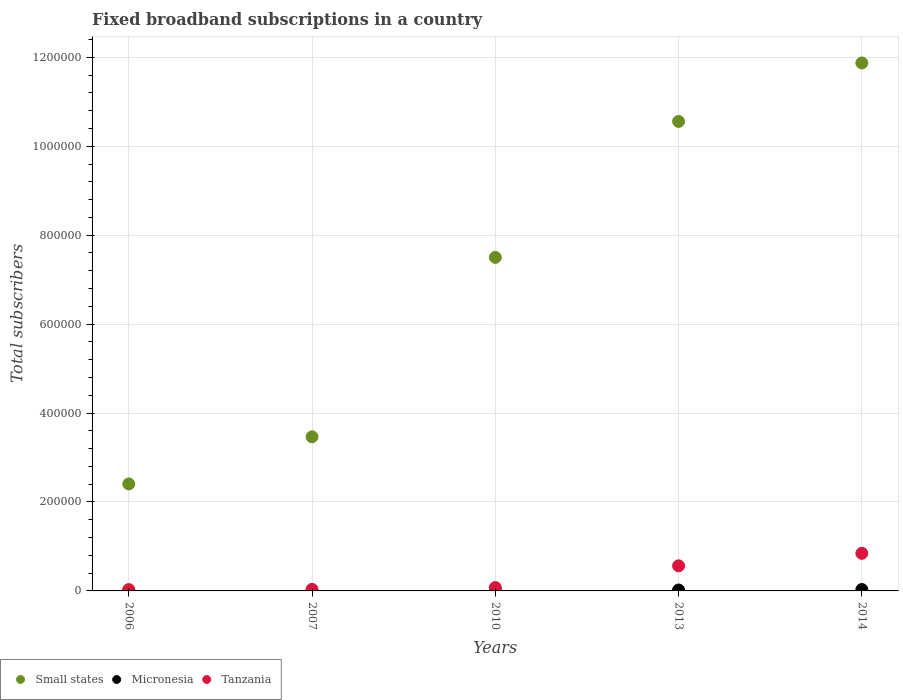How many different coloured dotlines are there?
Your answer should be very brief. 3. What is the number of broadband subscriptions in Tanzania in 2013?
Keep it short and to the point. 5.64e+04. Across all years, what is the maximum number of broadband subscriptions in Micronesia?
Make the answer very short. 3092. Across all years, what is the minimum number of broadband subscriptions in Tanzania?
Make the answer very short. 2998. In which year was the number of broadband subscriptions in Micronesia maximum?
Your answer should be very brief. 2014. In which year was the number of broadband subscriptions in Tanzania minimum?
Ensure brevity in your answer.  2006. What is the total number of broadband subscriptions in Small states in the graph?
Your response must be concise. 3.58e+06. What is the difference between the number of broadband subscriptions in Micronesia in 2007 and that in 2014?
Offer a very short reply. -2976. What is the difference between the number of broadband subscriptions in Micronesia in 2006 and the number of broadband subscriptions in Small states in 2013?
Offer a terse response. -1.06e+06. What is the average number of broadband subscriptions in Tanzania per year?
Offer a terse response. 3.10e+04. In the year 2007, what is the difference between the number of broadband subscriptions in Micronesia and number of broadband subscriptions in Small states?
Provide a short and direct response. -3.46e+05. What is the ratio of the number of broadband subscriptions in Small states in 2010 to that in 2013?
Keep it short and to the point. 0.71. Is the number of broadband subscriptions in Small states in 2006 less than that in 2007?
Your answer should be very brief. Yes. Is the difference between the number of broadband subscriptions in Micronesia in 2007 and 2013 greater than the difference between the number of broadband subscriptions in Small states in 2007 and 2013?
Provide a succinct answer. Yes. What is the difference between the highest and the second highest number of broadband subscriptions in Tanzania?
Keep it short and to the point. 2.82e+04. What is the difference between the highest and the lowest number of broadband subscriptions in Micronesia?
Your answer should be compact. 2997. In how many years, is the number of broadband subscriptions in Micronesia greater than the average number of broadband subscriptions in Micronesia taken over all years?
Your answer should be compact. 2. Is it the case that in every year, the sum of the number of broadband subscriptions in Small states and number of broadband subscriptions in Micronesia  is greater than the number of broadband subscriptions in Tanzania?
Provide a succinct answer. Yes. Does the number of broadband subscriptions in Tanzania monotonically increase over the years?
Your response must be concise. Yes. Is the number of broadband subscriptions in Small states strictly greater than the number of broadband subscriptions in Tanzania over the years?
Provide a short and direct response. Yes. What is the difference between two consecutive major ticks on the Y-axis?
Your answer should be compact. 2.00e+05. Does the graph contain grids?
Your answer should be very brief. Yes. Where does the legend appear in the graph?
Give a very brief answer. Bottom left. How many legend labels are there?
Your answer should be very brief. 3. How are the legend labels stacked?
Ensure brevity in your answer.  Horizontal. What is the title of the graph?
Provide a short and direct response. Fixed broadband subscriptions in a country. What is the label or title of the Y-axis?
Provide a short and direct response. Total subscribers. What is the Total subscribers in Small states in 2006?
Provide a short and direct response. 2.41e+05. What is the Total subscribers in Micronesia in 2006?
Provide a succinct answer. 95. What is the Total subscribers of Tanzania in 2006?
Your answer should be compact. 2998. What is the Total subscribers in Small states in 2007?
Make the answer very short. 3.47e+05. What is the Total subscribers of Micronesia in 2007?
Make the answer very short. 116. What is the Total subscribers in Tanzania in 2007?
Offer a very short reply. 3394. What is the Total subscribers of Small states in 2010?
Make the answer very short. 7.50e+05. What is the Total subscribers of Micronesia in 2010?
Provide a short and direct response. 998. What is the Total subscribers of Tanzania in 2010?
Keep it short and to the point. 7554. What is the Total subscribers of Small states in 2013?
Your response must be concise. 1.06e+06. What is the Total subscribers of Micronesia in 2013?
Keep it short and to the point. 2063. What is the Total subscribers in Tanzania in 2013?
Your answer should be compact. 5.64e+04. What is the Total subscribers of Small states in 2014?
Provide a short and direct response. 1.19e+06. What is the Total subscribers of Micronesia in 2014?
Ensure brevity in your answer.  3092. What is the Total subscribers in Tanzania in 2014?
Keep it short and to the point. 8.46e+04. Across all years, what is the maximum Total subscribers in Small states?
Offer a very short reply. 1.19e+06. Across all years, what is the maximum Total subscribers of Micronesia?
Your answer should be very brief. 3092. Across all years, what is the maximum Total subscribers of Tanzania?
Your answer should be very brief. 8.46e+04. Across all years, what is the minimum Total subscribers of Small states?
Your answer should be very brief. 2.41e+05. Across all years, what is the minimum Total subscribers in Micronesia?
Offer a terse response. 95. Across all years, what is the minimum Total subscribers of Tanzania?
Your answer should be very brief. 2998. What is the total Total subscribers in Small states in the graph?
Your answer should be compact. 3.58e+06. What is the total Total subscribers in Micronesia in the graph?
Provide a short and direct response. 6364. What is the total Total subscribers of Tanzania in the graph?
Your answer should be compact. 1.55e+05. What is the difference between the Total subscribers of Small states in 2006 and that in 2007?
Offer a terse response. -1.06e+05. What is the difference between the Total subscribers in Tanzania in 2006 and that in 2007?
Ensure brevity in your answer.  -396. What is the difference between the Total subscribers in Small states in 2006 and that in 2010?
Offer a terse response. -5.09e+05. What is the difference between the Total subscribers of Micronesia in 2006 and that in 2010?
Ensure brevity in your answer.  -903. What is the difference between the Total subscribers of Tanzania in 2006 and that in 2010?
Your response must be concise. -4556. What is the difference between the Total subscribers in Small states in 2006 and that in 2013?
Your answer should be very brief. -8.15e+05. What is the difference between the Total subscribers in Micronesia in 2006 and that in 2013?
Keep it short and to the point. -1968. What is the difference between the Total subscribers of Tanzania in 2006 and that in 2013?
Give a very brief answer. -5.34e+04. What is the difference between the Total subscribers in Small states in 2006 and that in 2014?
Provide a succinct answer. -9.47e+05. What is the difference between the Total subscribers in Micronesia in 2006 and that in 2014?
Keep it short and to the point. -2997. What is the difference between the Total subscribers of Tanzania in 2006 and that in 2014?
Offer a terse response. -8.16e+04. What is the difference between the Total subscribers in Small states in 2007 and that in 2010?
Ensure brevity in your answer.  -4.04e+05. What is the difference between the Total subscribers of Micronesia in 2007 and that in 2010?
Provide a succinct answer. -882. What is the difference between the Total subscribers of Tanzania in 2007 and that in 2010?
Make the answer very short. -4160. What is the difference between the Total subscribers of Small states in 2007 and that in 2013?
Provide a short and direct response. -7.09e+05. What is the difference between the Total subscribers of Micronesia in 2007 and that in 2013?
Ensure brevity in your answer.  -1947. What is the difference between the Total subscribers in Tanzania in 2007 and that in 2013?
Your answer should be very brief. -5.30e+04. What is the difference between the Total subscribers in Small states in 2007 and that in 2014?
Make the answer very short. -8.41e+05. What is the difference between the Total subscribers of Micronesia in 2007 and that in 2014?
Your response must be concise. -2976. What is the difference between the Total subscribers of Tanzania in 2007 and that in 2014?
Keep it short and to the point. -8.12e+04. What is the difference between the Total subscribers of Small states in 2010 and that in 2013?
Offer a very short reply. -3.06e+05. What is the difference between the Total subscribers in Micronesia in 2010 and that in 2013?
Offer a terse response. -1065. What is the difference between the Total subscribers of Tanzania in 2010 and that in 2013?
Provide a short and direct response. -4.89e+04. What is the difference between the Total subscribers of Small states in 2010 and that in 2014?
Provide a succinct answer. -4.37e+05. What is the difference between the Total subscribers of Micronesia in 2010 and that in 2014?
Keep it short and to the point. -2094. What is the difference between the Total subscribers of Tanzania in 2010 and that in 2014?
Offer a terse response. -7.70e+04. What is the difference between the Total subscribers of Small states in 2013 and that in 2014?
Ensure brevity in your answer.  -1.31e+05. What is the difference between the Total subscribers of Micronesia in 2013 and that in 2014?
Give a very brief answer. -1029. What is the difference between the Total subscribers of Tanzania in 2013 and that in 2014?
Give a very brief answer. -2.82e+04. What is the difference between the Total subscribers of Small states in 2006 and the Total subscribers of Micronesia in 2007?
Keep it short and to the point. 2.41e+05. What is the difference between the Total subscribers of Small states in 2006 and the Total subscribers of Tanzania in 2007?
Provide a succinct answer. 2.37e+05. What is the difference between the Total subscribers in Micronesia in 2006 and the Total subscribers in Tanzania in 2007?
Ensure brevity in your answer.  -3299. What is the difference between the Total subscribers of Small states in 2006 and the Total subscribers of Micronesia in 2010?
Offer a terse response. 2.40e+05. What is the difference between the Total subscribers of Small states in 2006 and the Total subscribers of Tanzania in 2010?
Keep it short and to the point. 2.33e+05. What is the difference between the Total subscribers in Micronesia in 2006 and the Total subscribers in Tanzania in 2010?
Your response must be concise. -7459. What is the difference between the Total subscribers of Small states in 2006 and the Total subscribers of Micronesia in 2013?
Your answer should be compact. 2.39e+05. What is the difference between the Total subscribers in Small states in 2006 and the Total subscribers in Tanzania in 2013?
Provide a succinct answer. 1.84e+05. What is the difference between the Total subscribers in Micronesia in 2006 and the Total subscribers in Tanzania in 2013?
Provide a succinct answer. -5.63e+04. What is the difference between the Total subscribers of Small states in 2006 and the Total subscribers of Micronesia in 2014?
Keep it short and to the point. 2.38e+05. What is the difference between the Total subscribers of Small states in 2006 and the Total subscribers of Tanzania in 2014?
Keep it short and to the point. 1.56e+05. What is the difference between the Total subscribers of Micronesia in 2006 and the Total subscribers of Tanzania in 2014?
Your answer should be compact. -8.45e+04. What is the difference between the Total subscribers of Small states in 2007 and the Total subscribers of Micronesia in 2010?
Provide a succinct answer. 3.46e+05. What is the difference between the Total subscribers of Small states in 2007 and the Total subscribers of Tanzania in 2010?
Offer a terse response. 3.39e+05. What is the difference between the Total subscribers in Micronesia in 2007 and the Total subscribers in Tanzania in 2010?
Provide a short and direct response. -7438. What is the difference between the Total subscribers in Small states in 2007 and the Total subscribers in Micronesia in 2013?
Offer a very short reply. 3.45e+05. What is the difference between the Total subscribers of Small states in 2007 and the Total subscribers of Tanzania in 2013?
Your answer should be compact. 2.90e+05. What is the difference between the Total subscribers in Micronesia in 2007 and the Total subscribers in Tanzania in 2013?
Give a very brief answer. -5.63e+04. What is the difference between the Total subscribers of Small states in 2007 and the Total subscribers of Micronesia in 2014?
Your answer should be compact. 3.43e+05. What is the difference between the Total subscribers of Small states in 2007 and the Total subscribers of Tanzania in 2014?
Offer a very short reply. 2.62e+05. What is the difference between the Total subscribers in Micronesia in 2007 and the Total subscribers in Tanzania in 2014?
Your answer should be very brief. -8.45e+04. What is the difference between the Total subscribers of Small states in 2010 and the Total subscribers of Micronesia in 2013?
Offer a very short reply. 7.48e+05. What is the difference between the Total subscribers in Small states in 2010 and the Total subscribers in Tanzania in 2013?
Your response must be concise. 6.94e+05. What is the difference between the Total subscribers in Micronesia in 2010 and the Total subscribers in Tanzania in 2013?
Give a very brief answer. -5.54e+04. What is the difference between the Total subscribers of Small states in 2010 and the Total subscribers of Micronesia in 2014?
Your response must be concise. 7.47e+05. What is the difference between the Total subscribers of Small states in 2010 and the Total subscribers of Tanzania in 2014?
Keep it short and to the point. 6.65e+05. What is the difference between the Total subscribers in Micronesia in 2010 and the Total subscribers in Tanzania in 2014?
Offer a terse response. -8.36e+04. What is the difference between the Total subscribers in Small states in 2013 and the Total subscribers in Micronesia in 2014?
Offer a terse response. 1.05e+06. What is the difference between the Total subscribers of Small states in 2013 and the Total subscribers of Tanzania in 2014?
Keep it short and to the point. 9.71e+05. What is the difference between the Total subscribers of Micronesia in 2013 and the Total subscribers of Tanzania in 2014?
Keep it short and to the point. -8.25e+04. What is the average Total subscribers in Small states per year?
Provide a short and direct response. 7.16e+05. What is the average Total subscribers of Micronesia per year?
Your answer should be compact. 1272.8. What is the average Total subscribers in Tanzania per year?
Make the answer very short. 3.10e+04. In the year 2006, what is the difference between the Total subscribers of Small states and Total subscribers of Micronesia?
Keep it short and to the point. 2.41e+05. In the year 2006, what is the difference between the Total subscribers in Small states and Total subscribers in Tanzania?
Offer a terse response. 2.38e+05. In the year 2006, what is the difference between the Total subscribers of Micronesia and Total subscribers of Tanzania?
Offer a terse response. -2903. In the year 2007, what is the difference between the Total subscribers of Small states and Total subscribers of Micronesia?
Your answer should be compact. 3.46e+05. In the year 2007, what is the difference between the Total subscribers of Small states and Total subscribers of Tanzania?
Keep it short and to the point. 3.43e+05. In the year 2007, what is the difference between the Total subscribers of Micronesia and Total subscribers of Tanzania?
Give a very brief answer. -3278. In the year 2010, what is the difference between the Total subscribers in Small states and Total subscribers in Micronesia?
Provide a short and direct response. 7.49e+05. In the year 2010, what is the difference between the Total subscribers of Small states and Total subscribers of Tanzania?
Ensure brevity in your answer.  7.43e+05. In the year 2010, what is the difference between the Total subscribers of Micronesia and Total subscribers of Tanzania?
Your answer should be very brief. -6556. In the year 2013, what is the difference between the Total subscribers in Small states and Total subscribers in Micronesia?
Your response must be concise. 1.05e+06. In the year 2013, what is the difference between the Total subscribers of Small states and Total subscribers of Tanzania?
Ensure brevity in your answer.  9.99e+05. In the year 2013, what is the difference between the Total subscribers of Micronesia and Total subscribers of Tanzania?
Make the answer very short. -5.44e+04. In the year 2014, what is the difference between the Total subscribers in Small states and Total subscribers in Micronesia?
Give a very brief answer. 1.18e+06. In the year 2014, what is the difference between the Total subscribers in Small states and Total subscribers in Tanzania?
Give a very brief answer. 1.10e+06. In the year 2014, what is the difference between the Total subscribers in Micronesia and Total subscribers in Tanzania?
Provide a short and direct response. -8.15e+04. What is the ratio of the Total subscribers of Small states in 2006 to that in 2007?
Your answer should be compact. 0.69. What is the ratio of the Total subscribers of Micronesia in 2006 to that in 2007?
Your answer should be very brief. 0.82. What is the ratio of the Total subscribers of Tanzania in 2006 to that in 2007?
Offer a terse response. 0.88. What is the ratio of the Total subscribers in Small states in 2006 to that in 2010?
Keep it short and to the point. 0.32. What is the ratio of the Total subscribers of Micronesia in 2006 to that in 2010?
Provide a succinct answer. 0.1. What is the ratio of the Total subscribers in Tanzania in 2006 to that in 2010?
Offer a terse response. 0.4. What is the ratio of the Total subscribers in Small states in 2006 to that in 2013?
Your answer should be very brief. 0.23. What is the ratio of the Total subscribers of Micronesia in 2006 to that in 2013?
Give a very brief answer. 0.05. What is the ratio of the Total subscribers in Tanzania in 2006 to that in 2013?
Provide a succinct answer. 0.05. What is the ratio of the Total subscribers of Small states in 2006 to that in 2014?
Keep it short and to the point. 0.2. What is the ratio of the Total subscribers of Micronesia in 2006 to that in 2014?
Provide a short and direct response. 0.03. What is the ratio of the Total subscribers of Tanzania in 2006 to that in 2014?
Give a very brief answer. 0.04. What is the ratio of the Total subscribers of Small states in 2007 to that in 2010?
Provide a succinct answer. 0.46. What is the ratio of the Total subscribers of Micronesia in 2007 to that in 2010?
Ensure brevity in your answer.  0.12. What is the ratio of the Total subscribers in Tanzania in 2007 to that in 2010?
Give a very brief answer. 0.45. What is the ratio of the Total subscribers in Small states in 2007 to that in 2013?
Ensure brevity in your answer.  0.33. What is the ratio of the Total subscribers in Micronesia in 2007 to that in 2013?
Offer a terse response. 0.06. What is the ratio of the Total subscribers of Tanzania in 2007 to that in 2013?
Offer a very short reply. 0.06. What is the ratio of the Total subscribers in Small states in 2007 to that in 2014?
Your answer should be very brief. 0.29. What is the ratio of the Total subscribers in Micronesia in 2007 to that in 2014?
Your response must be concise. 0.04. What is the ratio of the Total subscribers in Tanzania in 2007 to that in 2014?
Give a very brief answer. 0.04. What is the ratio of the Total subscribers in Small states in 2010 to that in 2013?
Ensure brevity in your answer.  0.71. What is the ratio of the Total subscribers in Micronesia in 2010 to that in 2013?
Your response must be concise. 0.48. What is the ratio of the Total subscribers of Tanzania in 2010 to that in 2013?
Give a very brief answer. 0.13. What is the ratio of the Total subscribers of Small states in 2010 to that in 2014?
Provide a succinct answer. 0.63. What is the ratio of the Total subscribers of Micronesia in 2010 to that in 2014?
Offer a terse response. 0.32. What is the ratio of the Total subscribers of Tanzania in 2010 to that in 2014?
Your answer should be very brief. 0.09. What is the ratio of the Total subscribers of Small states in 2013 to that in 2014?
Your answer should be compact. 0.89. What is the ratio of the Total subscribers in Micronesia in 2013 to that in 2014?
Give a very brief answer. 0.67. What is the ratio of the Total subscribers of Tanzania in 2013 to that in 2014?
Keep it short and to the point. 0.67. What is the difference between the highest and the second highest Total subscribers in Small states?
Offer a terse response. 1.31e+05. What is the difference between the highest and the second highest Total subscribers of Micronesia?
Give a very brief answer. 1029. What is the difference between the highest and the second highest Total subscribers of Tanzania?
Your answer should be compact. 2.82e+04. What is the difference between the highest and the lowest Total subscribers in Small states?
Your answer should be very brief. 9.47e+05. What is the difference between the highest and the lowest Total subscribers in Micronesia?
Your answer should be very brief. 2997. What is the difference between the highest and the lowest Total subscribers of Tanzania?
Your answer should be very brief. 8.16e+04. 